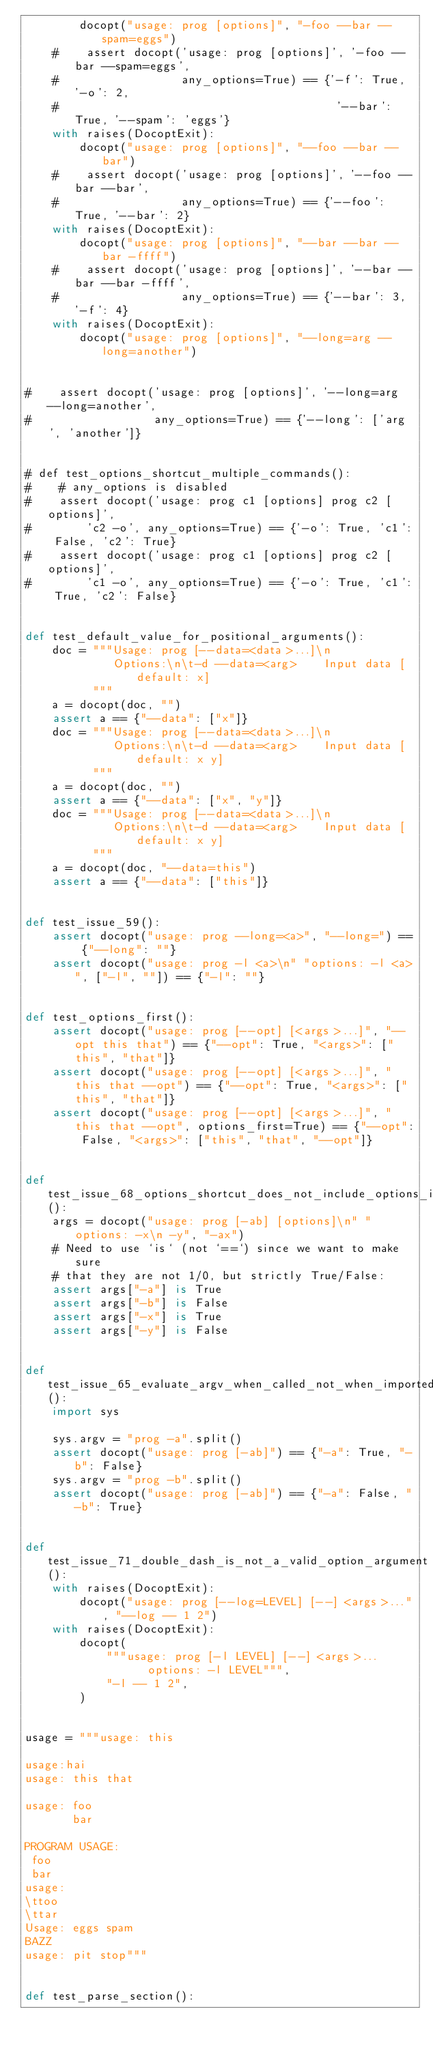<code> <loc_0><loc_0><loc_500><loc_500><_Python_>        docopt("usage: prog [options]", "-foo --bar --spam=eggs")
    #    assert docopt('usage: prog [options]', '-foo --bar --spam=eggs',
    #                  any_options=True) == {'-f': True, '-o': 2,
    #                                         '--bar': True, '--spam': 'eggs'}
    with raises(DocoptExit):
        docopt("usage: prog [options]", "--foo --bar --bar")
    #    assert docopt('usage: prog [options]', '--foo --bar --bar',
    #                  any_options=True) == {'--foo': True, '--bar': 2}
    with raises(DocoptExit):
        docopt("usage: prog [options]", "--bar --bar --bar -ffff")
    #    assert docopt('usage: prog [options]', '--bar --bar --bar -ffff',
    #                  any_options=True) == {'--bar': 3, '-f': 4}
    with raises(DocoptExit):
        docopt("usage: prog [options]", "--long=arg --long=another")


#    assert docopt('usage: prog [options]', '--long=arg --long=another',
#                  any_options=True) == {'--long': ['arg', 'another']}


# def test_options_shortcut_multiple_commands():
#    # any_options is disabled
#    assert docopt('usage: prog c1 [options] prog c2 [options]',
#        'c2 -o', any_options=True) == {'-o': True, 'c1': False, 'c2': True}
#    assert docopt('usage: prog c1 [options] prog c2 [options]',
#        'c1 -o', any_options=True) == {'-o': True, 'c1': True, 'c2': False}


def test_default_value_for_positional_arguments():
    doc = """Usage: prog [--data=<data>...]\n
             Options:\n\t-d --data=<arg>    Input data [default: x]
          """
    a = docopt(doc, "")
    assert a == {"--data": ["x"]}
    doc = """Usage: prog [--data=<data>...]\n
             Options:\n\t-d --data=<arg>    Input data [default: x y]
          """
    a = docopt(doc, "")
    assert a == {"--data": ["x", "y"]}
    doc = """Usage: prog [--data=<data>...]\n
             Options:\n\t-d --data=<arg>    Input data [default: x y]
          """
    a = docopt(doc, "--data=this")
    assert a == {"--data": ["this"]}


def test_issue_59():
    assert docopt("usage: prog --long=<a>", "--long=") == {"--long": ""}
    assert docopt("usage: prog -l <a>\n" "options: -l <a>", ["-l", ""]) == {"-l": ""}


def test_options_first():
    assert docopt("usage: prog [--opt] [<args>...]", "--opt this that") == {"--opt": True, "<args>": ["this", "that"]}
    assert docopt("usage: prog [--opt] [<args>...]", "this that --opt") == {"--opt": True, "<args>": ["this", "that"]}
    assert docopt("usage: prog [--opt] [<args>...]", "this that --opt", options_first=True) == {"--opt": False, "<args>": ["this", "that", "--opt"]}


def test_issue_68_options_shortcut_does_not_include_options_in_usage_pattern():
    args = docopt("usage: prog [-ab] [options]\n" "options: -x\n -y", "-ax")
    # Need to use `is` (not `==`) since we want to make sure
    # that they are not 1/0, but strictly True/False:
    assert args["-a"] is True
    assert args["-b"] is False
    assert args["-x"] is True
    assert args["-y"] is False


def test_issue_65_evaluate_argv_when_called_not_when_imported():
    import sys

    sys.argv = "prog -a".split()
    assert docopt("usage: prog [-ab]") == {"-a": True, "-b": False}
    sys.argv = "prog -b".split()
    assert docopt("usage: prog [-ab]") == {"-a": False, "-b": True}


def test_issue_71_double_dash_is_not_a_valid_option_argument():
    with raises(DocoptExit):
        docopt("usage: prog [--log=LEVEL] [--] <args>...", "--log -- 1 2")
    with raises(DocoptExit):
        docopt(
            """usage: prog [-l LEVEL] [--] <args>...
                  options: -l LEVEL""",
            "-l -- 1 2",
        )


usage = """usage: this

usage:hai
usage: this that

usage: foo
       bar

PROGRAM USAGE:
 foo
 bar
usage:
\ttoo
\ttar
Usage: eggs spam
BAZZ
usage: pit stop"""


def test_parse_section():</code> 